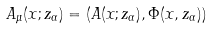Convert formula to latex. <formula><loc_0><loc_0><loc_500><loc_500>A _ { \mu } ( { x } ; z _ { \alpha } ) = ( { A } ( { x } ; z _ { \alpha } ) , \Phi ( { x } , z _ { \alpha } ) )</formula> 